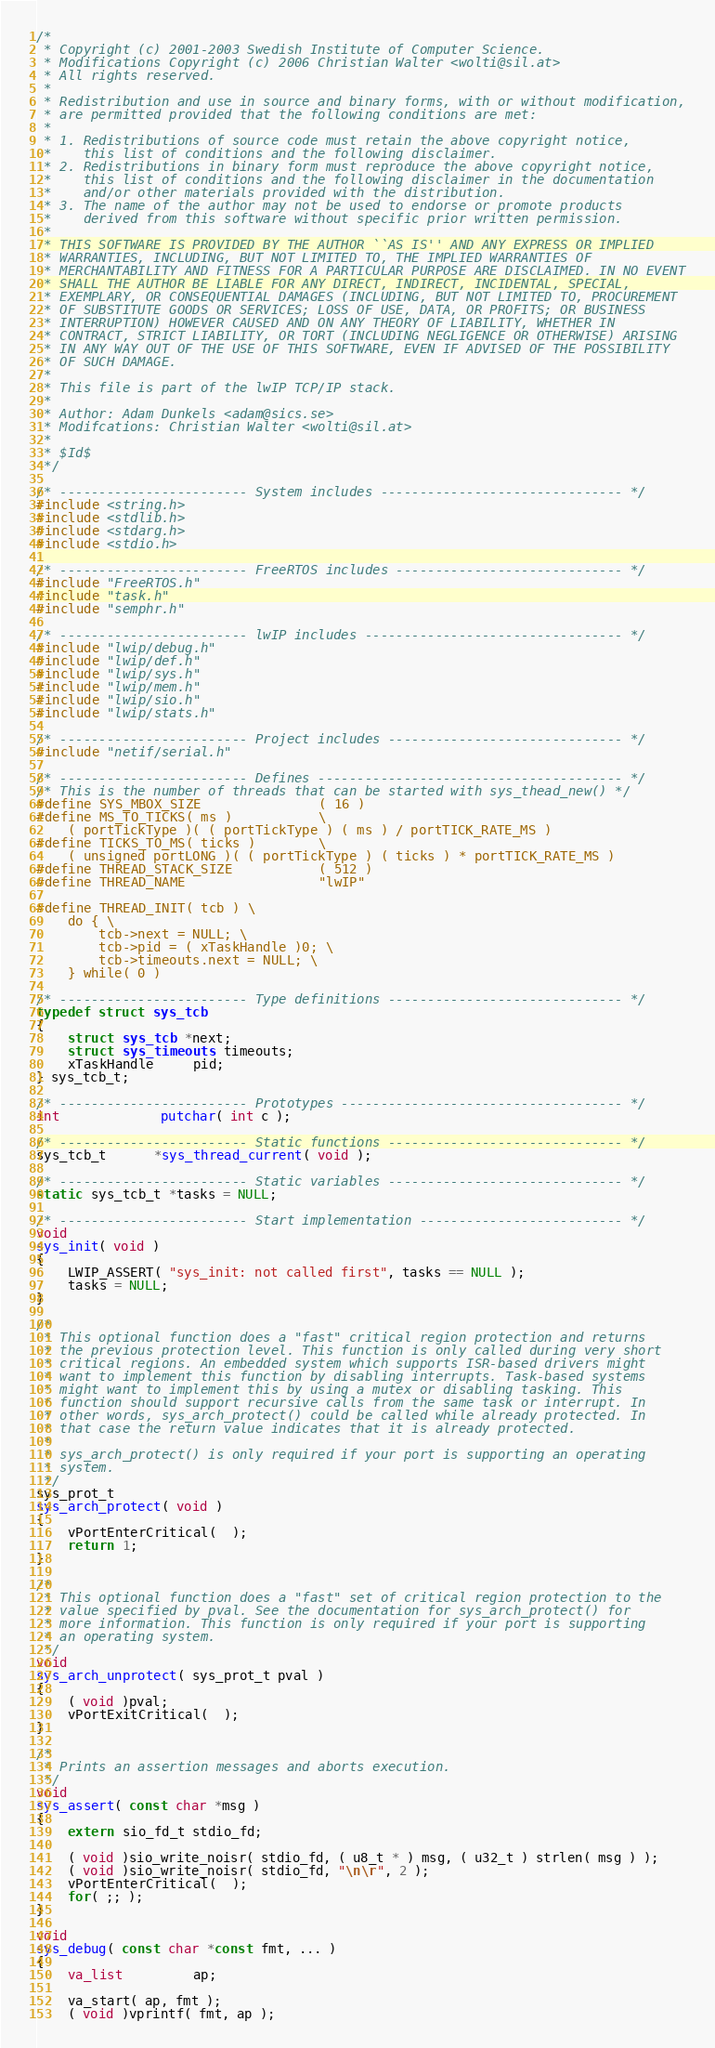<code> <loc_0><loc_0><loc_500><loc_500><_C_>/*
 * Copyright (c) 2001-2003 Swedish Institute of Computer Science.
 * Modifications Copyright (c) 2006 Christian Walter <wolti@sil.at>
 * All rights reserved.
 *
 * Redistribution and use in source and binary forms, with or without modification,
 * are permitted provided that the following conditions are met:
 *
 * 1. Redistributions of source code must retain the above copyright notice,
 *    this list of conditions and the following disclaimer.
 * 2. Redistributions in binary form must reproduce the above copyright notice,
 *    this list of conditions and the following disclaimer in the documentation
 *    and/or other materials provided with the distribution.
 * 3. The name of the author may not be used to endorse or promote products
 *    derived from this software without specific prior written permission.
 *
 * THIS SOFTWARE IS PROVIDED BY THE AUTHOR ``AS IS'' AND ANY EXPRESS OR IMPLIED
 * WARRANTIES, INCLUDING, BUT NOT LIMITED TO, THE IMPLIED WARRANTIES OF
 * MERCHANTABILITY AND FITNESS FOR A PARTICULAR PURPOSE ARE DISCLAIMED. IN NO EVENT
 * SHALL THE AUTHOR BE LIABLE FOR ANY DIRECT, INDIRECT, INCIDENTAL, SPECIAL,
 * EXEMPLARY, OR CONSEQUENTIAL DAMAGES (INCLUDING, BUT NOT LIMITED TO, PROCUREMENT
 * OF SUBSTITUTE GOODS OR SERVICES; LOSS OF USE, DATA, OR PROFITS; OR BUSINESS
 * INTERRUPTION) HOWEVER CAUSED AND ON ANY THEORY OF LIABILITY, WHETHER IN
 * CONTRACT, STRICT LIABILITY, OR TORT (INCLUDING NEGLIGENCE OR OTHERWISE) ARISING
 * IN ANY WAY OUT OF THE USE OF THIS SOFTWARE, EVEN IF ADVISED OF THE POSSIBILITY
 * OF SUCH DAMAGE.
 *
 * This file is part of the lwIP TCP/IP stack.
 *
 * Author: Adam Dunkels <adam@sics.se>
 * Modifcations: Christian Walter <wolti@sil.at>
 *
 * $Id$
 */

/* ------------------------ System includes ------------------------------- */
#include <string.h>
#include <stdlib.h>
#include <stdarg.h>
#include <stdio.h>

/* ------------------------ FreeRTOS includes ----------------------------- */
#include "FreeRTOS.h"
#include "task.h"
#include "semphr.h"

/* ------------------------ lwIP includes --------------------------------- */
#include "lwip/debug.h"
#include "lwip/def.h"
#include "lwip/sys.h"
#include "lwip/mem.h"
#include "lwip/sio.h"
#include "lwip/stats.h"

/* ------------------------ Project includes ------------------------------ */
#include "netif/serial.h"

/* ------------------------ Defines --------------------------------------- */
/* This is the number of threads that can be started with sys_thead_new() */
#define SYS_MBOX_SIZE               ( 16 )
#define MS_TO_TICKS( ms )           \
    ( portTickType )( ( portTickType ) ( ms ) / portTICK_RATE_MS )
#define TICKS_TO_MS( ticks )        \
    ( unsigned portLONG )( ( portTickType ) ( ticks ) * portTICK_RATE_MS )
#define THREAD_STACK_SIZE           ( 512 )
#define THREAD_NAME                 "lwIP"

#define THREAD_INIT( tcb ) \
    do { \
        tcb->next = NULL; \
        tcb->pid = ( xTaskHandle )0; \
        tcb->timeouts.next = NULL; \
    } while( 0 )

/* ------------------------ Type definitions ------------------------------ */
typedef struct sys_tcb
{
    struct sys_tcb *next;
    struct sys_timeouts timeouts;
    xTaskHandle     pid;
} sys_tcb_t;

/* ------------------------ Prototypes ------------------------------------ */
int             putchar( int c );

/* ------------------------ Static functions ------------------------------ */
sys_tcb_t      *sys_thread_current( void );

/* ------------------------ Static variables ------------------------------ */
static sys_tcb_t *tasks = NULL;

/* ------------------------ Start implementation -------------------------- */
void
sys_init( void )
{
    LWIP_ASSERT( "sys_init: not called first", tasks == NULL );
    tasks = NULL;
}

/*
 * This optional function does a "fast" critical region protection and returns
 * the previous protection level. This function is only called during very short
 * critical regions. An embedded system which supports ISR-based drivers might
 * want to implement this function by disabling interrupts. Task-based systems
 * might want to implement this by using a mutex or disabling tasking. This
 * function should support recursive calls from the same task or interrupt. In
 * other words, sys_arch_protect() could be called while already protected. In
 * that case the return value indicates that it is already protected.
 *
 * sys_arch_protect() is only required if your port is supporting an operating
 * system.
 */
sys_prot_t
sys_arch_protect( void )
{
    vPortEnterCritical(  );
    return 1;
}

/*
 * This optional function does a "fast" set of critical region protection to the
 * value specified by pval. See the documentation for sys_arch_protect() for
 * more information. This function is only required if your port is supporting
 * an operating system.
 */
void
sys_arch_unprotect( sys_prot_t pval )
{
    ( void )pval;
    vPortExitCritical(  );
}

/*
 * Prints an assertion messages and aborts execution.
 */
void
sys_assert( const char *msg )
{
    extern sio_fd_t stdio_fd;

    ( void )sio_write_noisr( stdio_fd, ( u8_t * ) msg, ( u32_t ) strlen( msg ) );
    ( void )sio_write_noisr( stdio_fd, "\n\r", 2 );
    vPortEnterCritical(  );
    for( ;; );
}

void
sys_debug( const char *const fmt, ... )
{
    va_list         ap;

    va_start( ap, fmt );
    ( void )vprintf( fmt, ap );</code> 